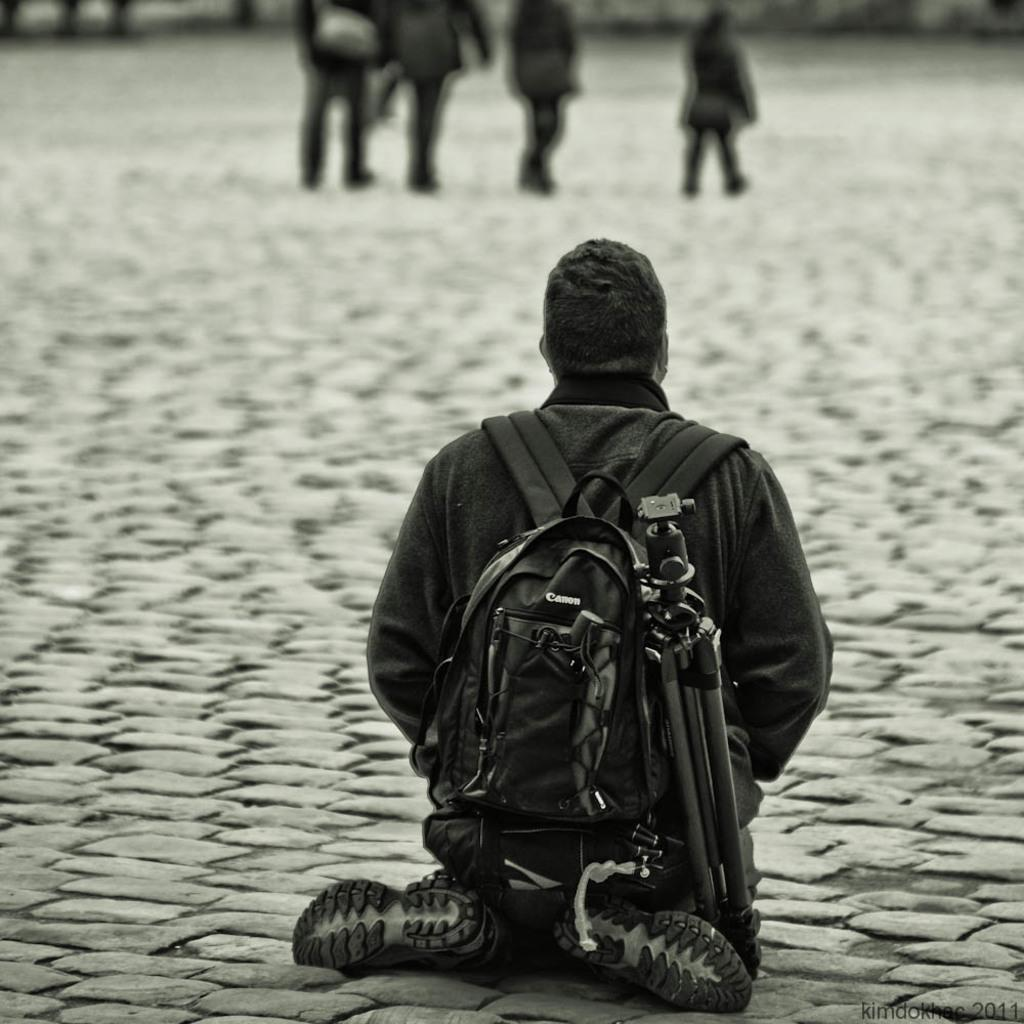Who is present in the image? There is a person in the image. What is the person doing in the image? The person is carrying a bag and sitting on the ground. Can you describe the surroundings of the person? There are people visible in the background of the image. What type of soup is the person eating in the image? There is no soup present in the image; the person is carrying a bag and sitting on the ground. 